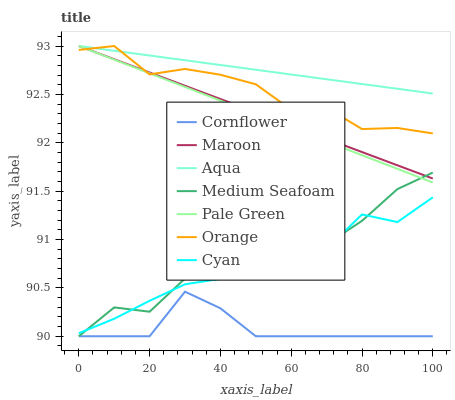Does Maroon have the minimum area under the curve?
Answer yes or no. No. Does Maroon have the maximum area under the curve?
Answer yes or no. No. Is Aqua the smoothest?
Answer yes or no. No. Is Aqua the roughest?
Answer yes or no. No. Does Maroon have the lowest value?
Answer yes or no. No. Does Cyan have the highest value?
Answer yes or no. No. Is Medium Seafoam less than Orange?
Answer yes or no. Yes. Is Aqua greater than Cornflower?
Answer yes or no. Yes. Does Medium Seafoam intersect Orange?
Answer yes or no. No. 